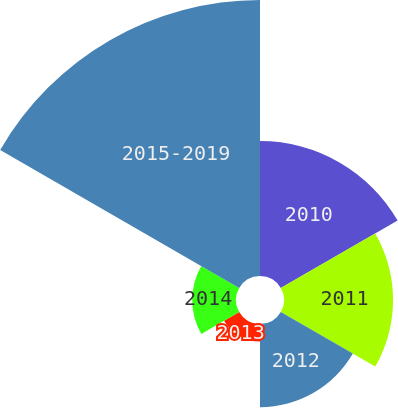Convert chart to OTSL. <chart><loc_0><loc_0><loc_500><loc_500><pie_chart><fcel>2010<fcel>2011<fcel>2012<fcel>2013<fcel>2014<fcel>2015-2019<nl><fcel>20.3%<fcel>16.41%<fcel>12.52%<fcel>2.64%<fcel>6.59%<fcel>41.53%<nl></chart> 